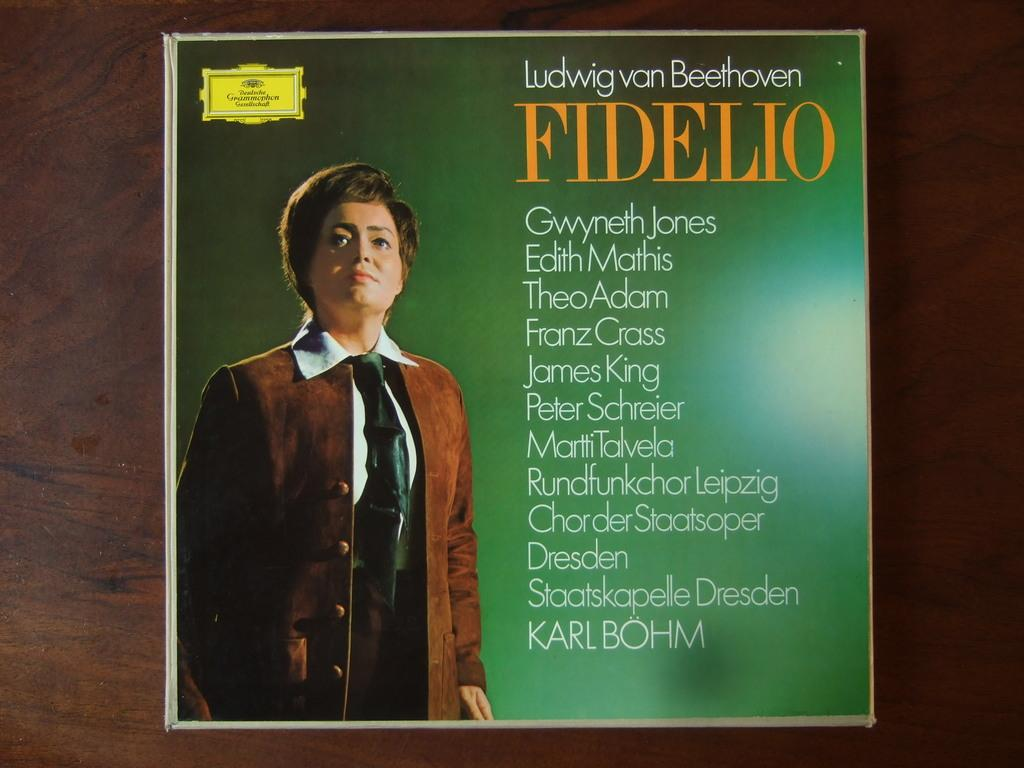<image>
Describe the image concisely. A CD cover with the title Ludwig von Beethoven. 